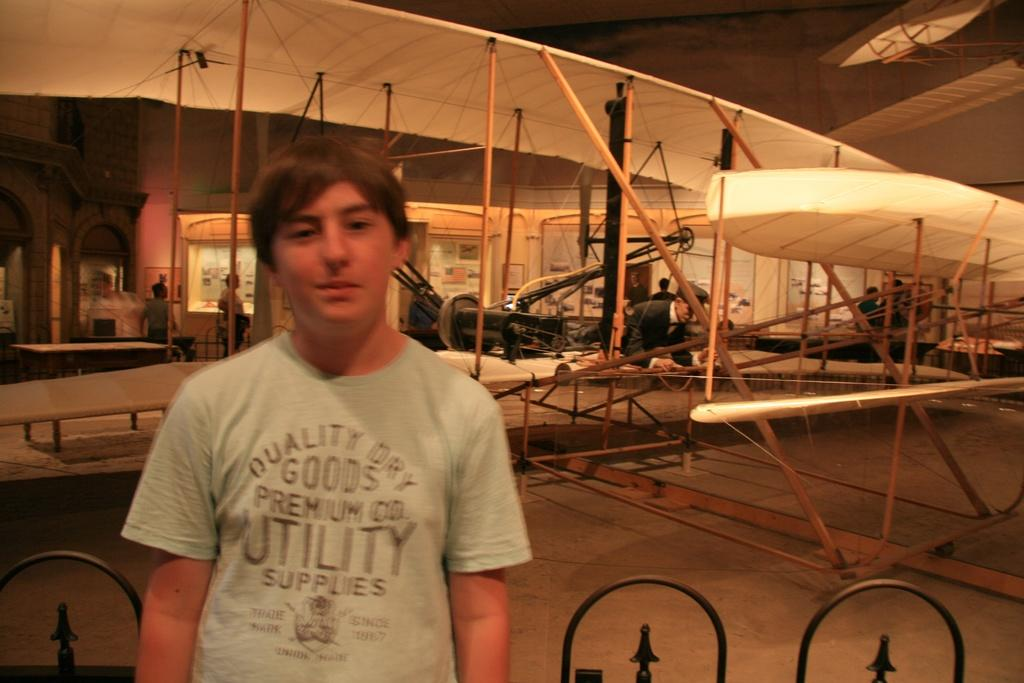Who is the main subject in the image? There is a boy in the image. What can be seen in the background of the image? There is an aircraft construction and a man in the background. Are there any other people visible in the image? Yes, there are people sitting in the background. What type of oil is being used to balance the aircraft construction in the image? There is no oil or mention of balancing the aircraft construction in the image. 